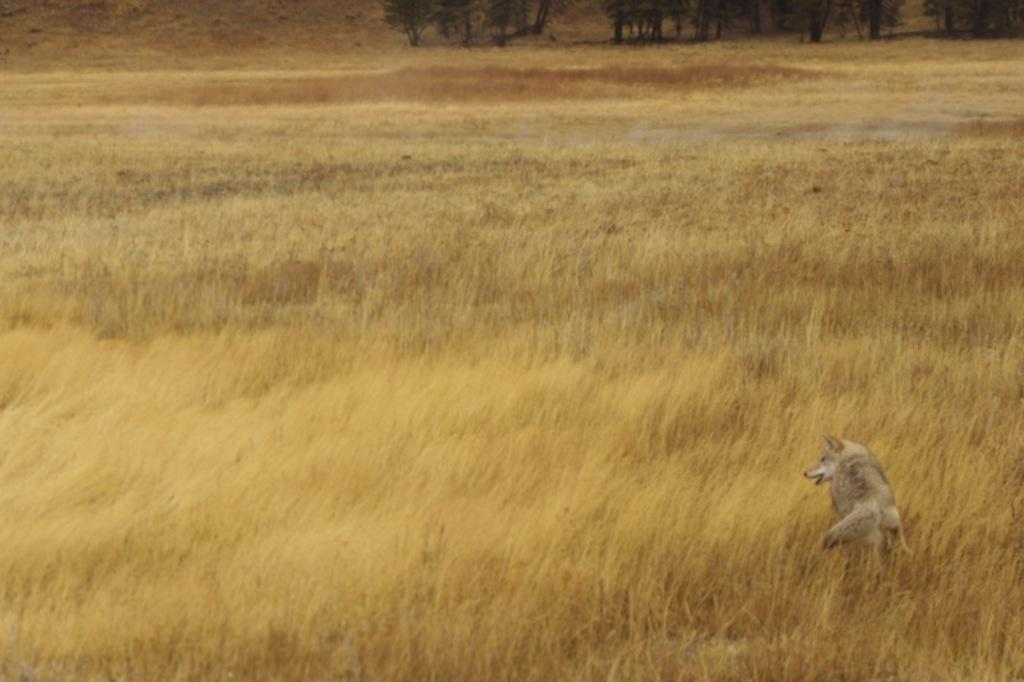What animal is located on the right side of the image? There is a fox on the right side of the image. What is the fox standing on? The fox is on the grass. What type of vegetation can be seen in the background of the image? There is grass and trees visible in the background of the image. What type of bubble can be seen floating near the fox in the image? There is no bubble present in the image; it only features a fox on the grass with trees in the background. 